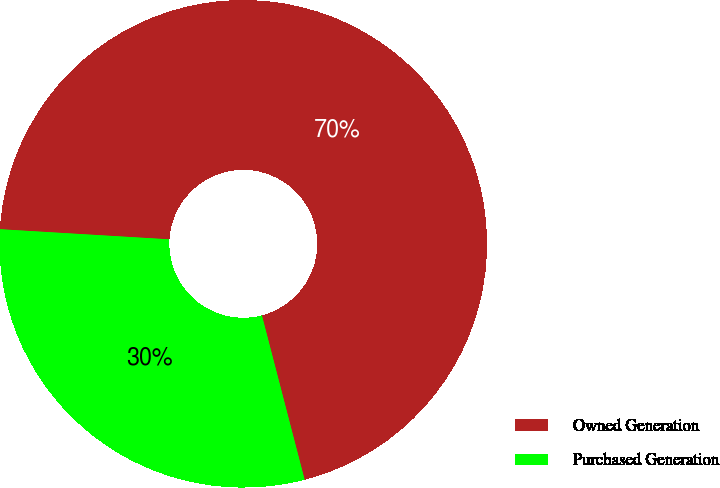Convert chart. <chart><loc_0><loc_0><loc_500><loc_500><pie_chart><fcel>Owned Generation<fcel>Purchased Generation<nl><fcel>70.0%<fcel>30.0%<nl></chart> 